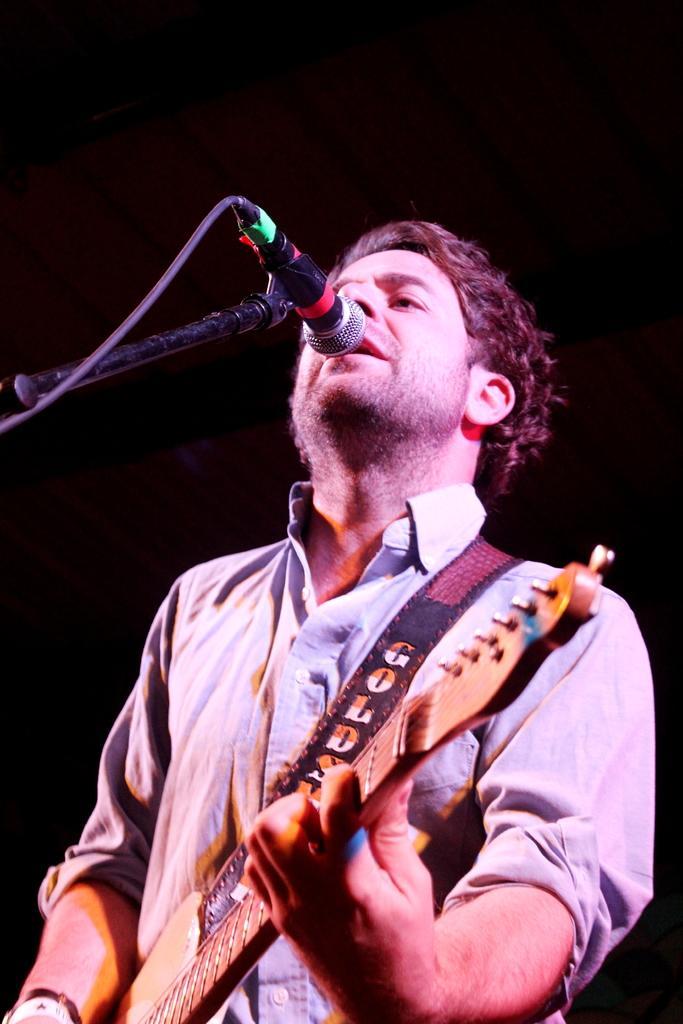In one or two sentences, can you explain what this image depicts? In the picture a man is standing and playing the guitar he is also singing a song there is a mic in front of him ,in the background it is black color. 